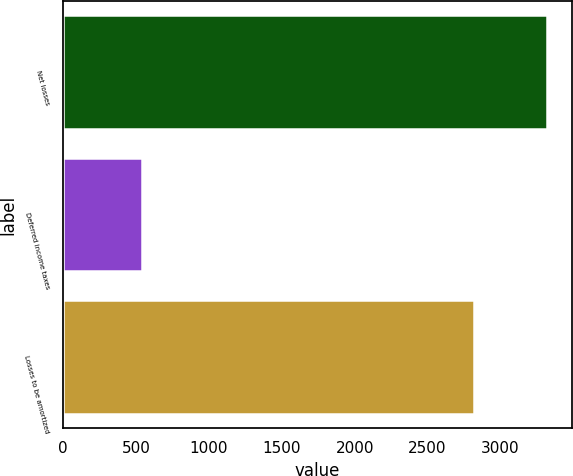<chart> <loc_0><loc_0><loc_500><loc_500><bar_chart><fcel>Net losses<fcel>Deferred income taxes<fcel>Losses to be amortized<nl><fcel>3321<fcel>541<fcel>2816<nl></chart> 